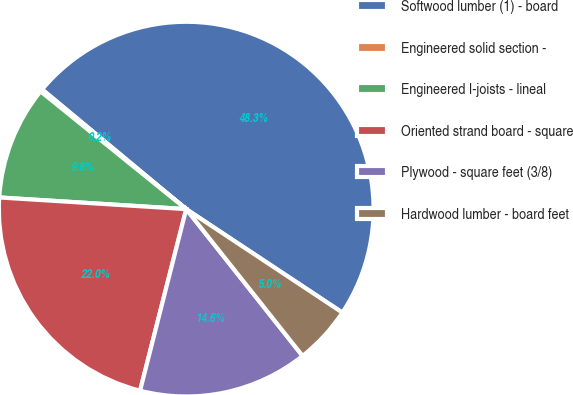Convert chart to OTSL. <chart><loc_0><loc_0><loc_500><loc_500><pie_chart><fcel>Softwood lumber (1) - board<fcel>Engineered solid section -<fcel>Engineered I-joists - lineal<fcel>Oriented strand board - square<fcel>Plywood - square feet (3/8)<fcel>Hardwood lumber - board feet<nl><fcel>48.28%<fcel>0.21%<fcel>9.83%<fcel>22.03%<fcel>14.63%<fcel>5.02%<nl></chart> 